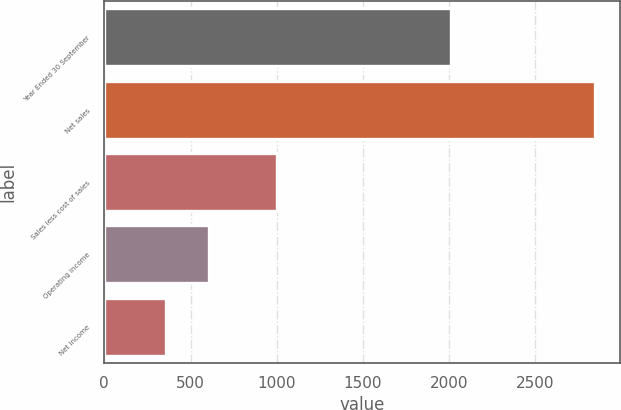Convert chart to OTSL. <chart><loc_0><loc_0><loc_500><loc_500><bar_chart><fcel>Year Ended 30 September<fcel>Net sales<fcel>Sales less cost of sales<fcel>Operating income<fcel>Net income<nl><fcel>2013<fcel>2845.9<fcel>1003.3<fcel>609.04<fcel>360.5<nl></chart> 